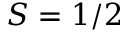Convert formula to latex. <formula><loc_0><loc_0><loc_500><loc_500>S = 1 / 2</formula> 